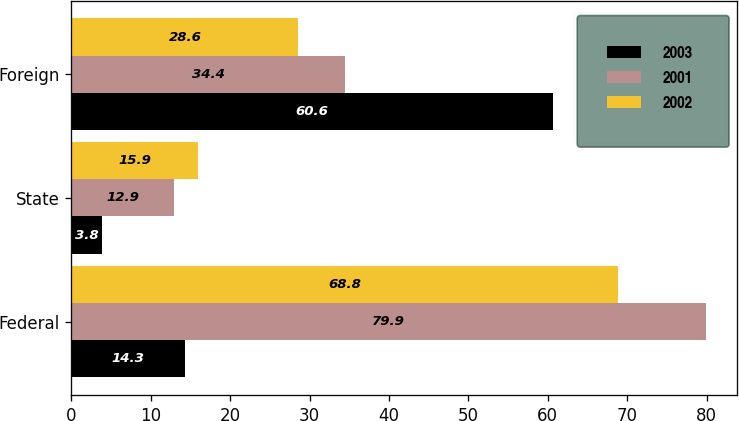<chart> <loc_0><loc_0><loc_500><loc_500><stacked_bar_chart><ecel><fcel>Federal<fcel>State<fcel>Foreign<nl><fcel>2003<fcel>14.3<fcel>3.8<fcel>60.6<nl><fcel>2001<fcel>79.9<fcel>12.9<fcel>34.4<nl><fcel>2002<fcel>68.8<fcel>15.9<fcel>28.6<nl></chart> 